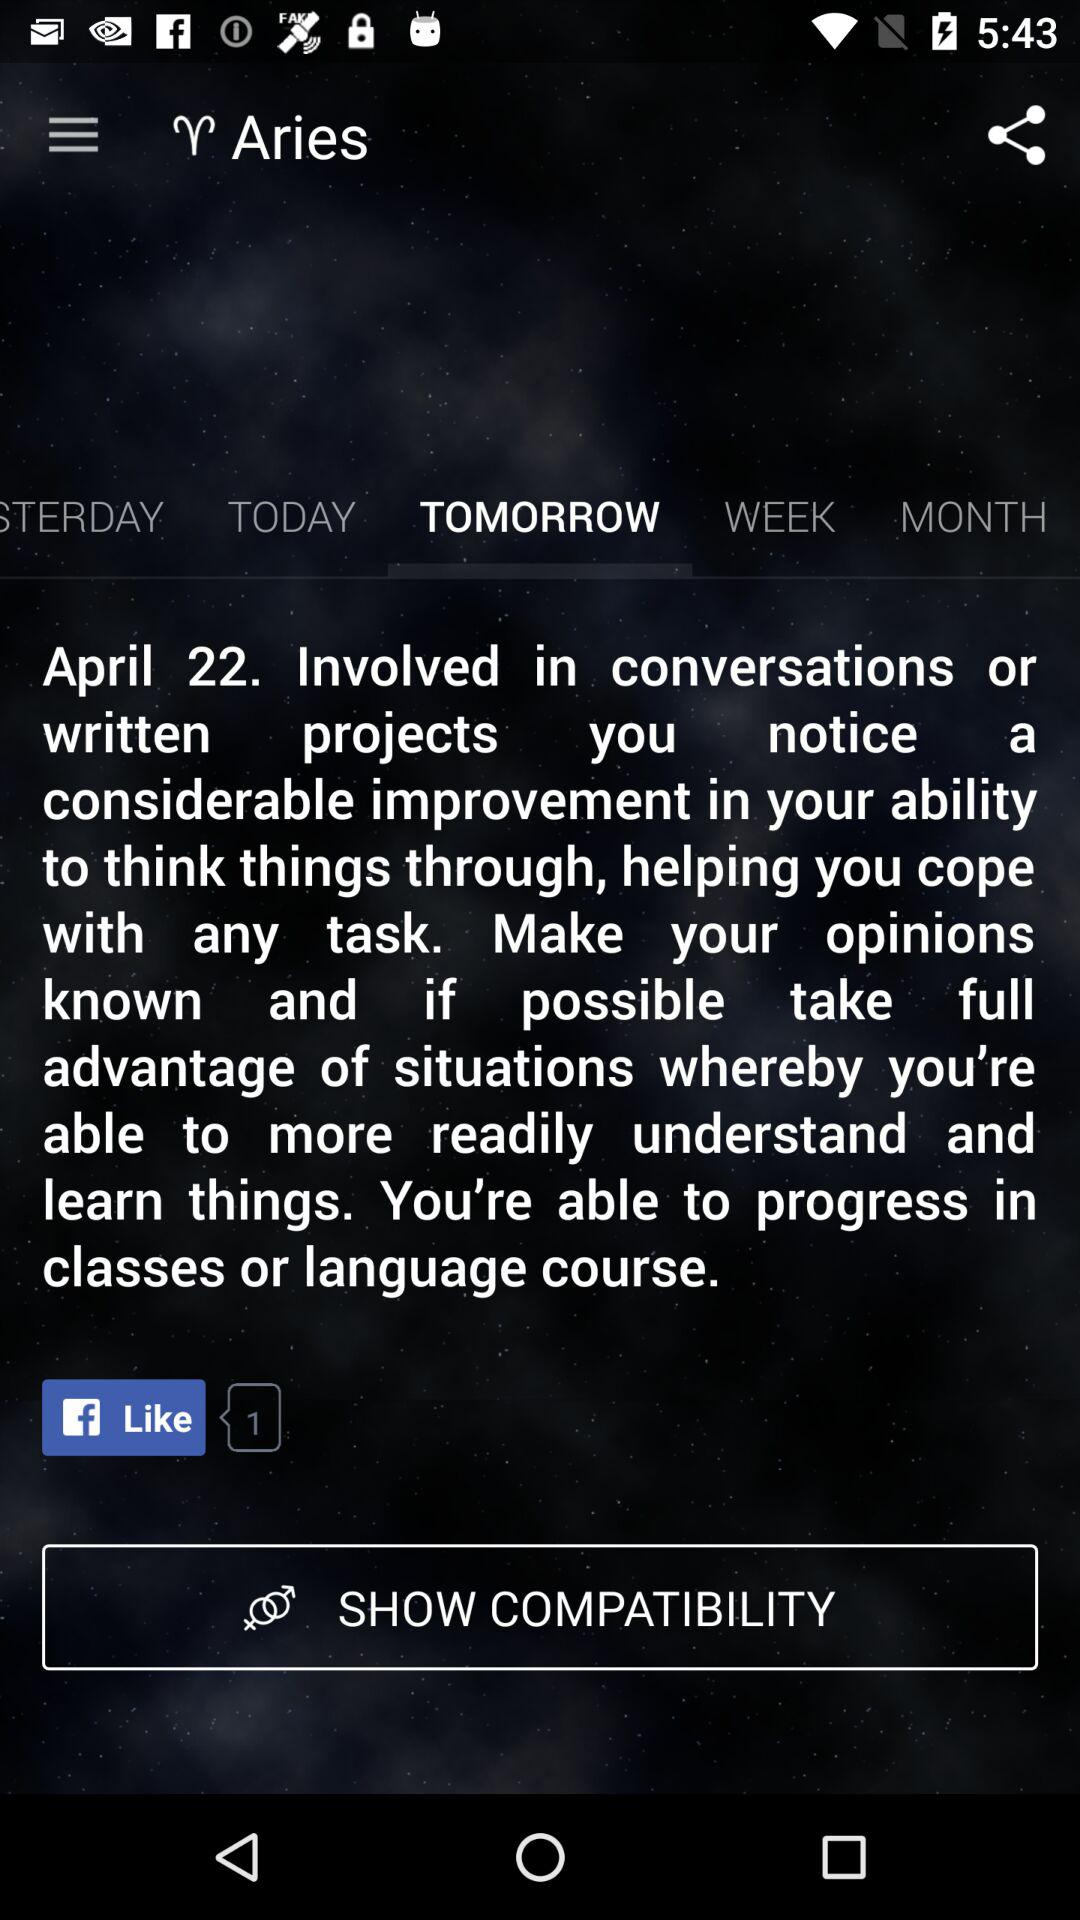What is the selected option? The selected option is "TOMORROW". 